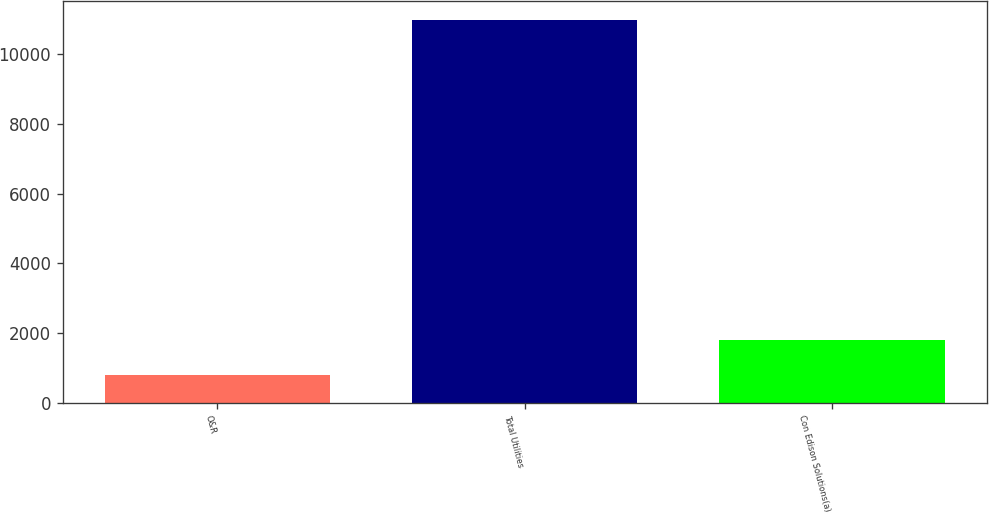Convert chart. <chart><loc_0><loc_0><loc_500><loc_500><bar_chart><fcel>O&R<fcel>Total Utilities<fcel>Con Edison Solutions(a)<nl><fcel>795<fcel>10982<fcel>1813.7<nl></chart> 